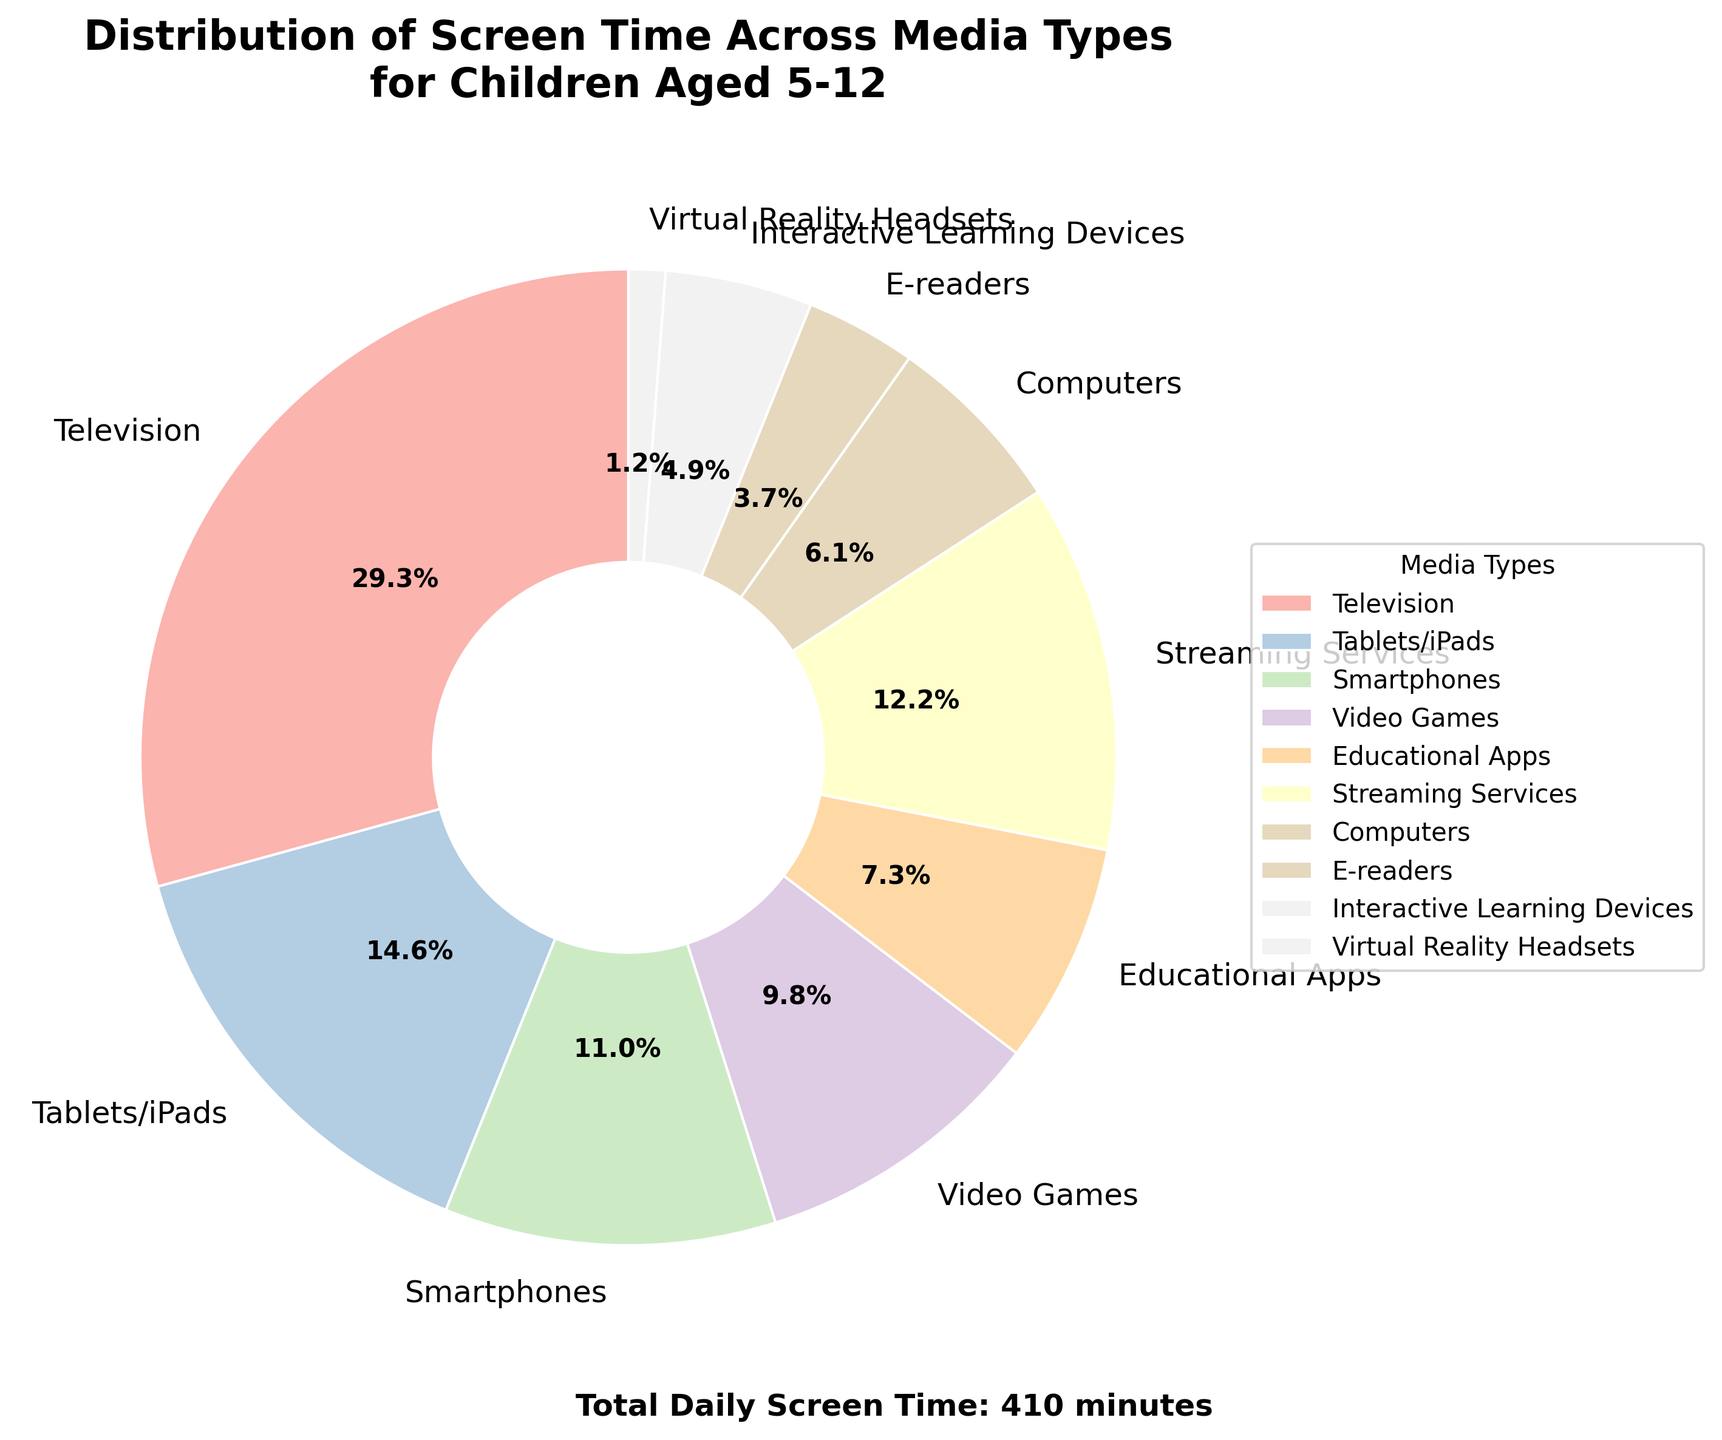What percentage of daily screen time is spent on watching television? Locate the section of the pie chart corresponding to "Television" and find the percentage label attached to it, which is 33.6%.
Answer: 33.6% How does the screen time spent on educational apps compare to that on video games? Find the segments labeled "Educational Apps" and "Video Games". The percentages are 8.4% for Educational Apps and 11.2% for Video Games. Since 11.2% is greater than 8.4%, more screen time is spent on Video Games.
Answer: More time is spent on Video Games What is the total screen time spent on smartphones and tablets/iPads combined? Identify the percentages from the pie chart for "Smartphones" (12.6%) and "Tablets/iPads" (16.8%). Calculate the sum: 12.6% + 16.8% = 29.4%.
Answer: 29.4% Which media type has the least screen time and what is that percentage? Locate the smallest segment in the pie chart, which represents the "Virtual Reality Headsets" with a percentage of 1.4%.
Answer: Virtual Reality Headsets, 1.4% How much more screen time is dedicated to streaming services compared to computers? Find the segments for "Streaming Services" (14.0%) and "Computers" (7.0%). Subtract the smaller percentage from the larger one: 14.0% - 7.0% = 7.0%.
Answer: 7.0% Is the combined screen time of e-readers and interactive learning devices more than that of smartphones? Find the percentages for "E-readers" (4.2%) and "Interactive Learning Devices" (5.6%), then sum them: 4.2% + 5.6% = 9.8%. Compare this to "Smartphones" (12.6%). 9.8% is less than 12.6%.
Answer: No Which three media types contribute the most to the total screen time? Identify the three largest segments in the pie chart, which are "Television" (33.6%), "Tablets/iPads" (16.8%), and "Smartphones" (12.6%).
Answer: Television, Tablets/iPads, Smartphones How does the screen time for streaming services compare visually to that of interactive learning devices? Visually locate the segments for "Streaming Services" and "Interactive Learning Devices". The segment for Streaming Services is larger than that for Interactive Learning Devices, indicating a higher percentage.
Answer: Streaming Services is larger What is the total screen time spent on streaming services, video games, and educational apps combined? Identify the segments and their percentages: "Streaming Services" (14.0%), "Video Games" (11.2%), and "Educational Apps" (8.4%). Calculate the sum: 14.0% + 11.2% + 8.4% = 33.6%.
Answer: 33.6% What percentage of screen time is spent on non-educational activities? Identify the percentages for all non-educational activities: "Television" (33.6%), "Tablets/iPads" (16.8%), "Smartphones" (12.6%), "Video Games" (11.2%), "Streaming Services" (14.0%). Calculate the sum: 33.6% + 16.8% + 12.6% + 11.2% + 14.0% = 88.2%.
Answer: 88.2% 